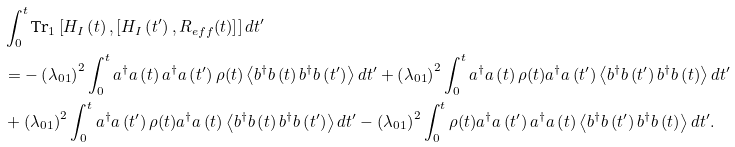Convert formula to latex. <formula><loc_0><loc_0><loc_500><loc_500>& \int _ { 0 } ^ { t } \text {Tr} _ { 1 } \left [ H _ { I } \left ( t \right ) , \left [ H _ { I } \left ( t ^ { \prime } \right ) , R _ { e f f } ( t ) \right ] \right ] d t ^ { \prime } \\ & = - \left ( \lambda _ { 0 1 } \right ) ^ { 2 } \int _ { 0 } ^ { t } a ^ { \dagger } a \left ( t \right ) a ^ { \dagger } a \left ( t ^ { \prime } \right ) \rho ( t ) \left \langle b ^ { \dagger } b \left ( t \right ) b ^ { \dagger } b \left ( t ^ { \prime } \right ) \right \rangle d t ^ { \prime } + \left ( \lambda _ { 0 1 } \right ) ^ { 2 } \int _ { 0 } ^ { t } a ^ { \dagger } a \left ( t \right ) \rho ( t ) a ^ { \dagger } a \left ( t ^ { \prime } \right ) \left \langle b ^ { \dagger } b \left ( t ^ { \prime } \right ) b ^ { \dagger } b \left ( t \right ) \right \rangle d t ^ { \prime } \\ & + \left ( \lambda _ { 0 1 } \right ) ^ { 2 } \int _ { 0 } ^ { t } a ^ { \dagger } a \left ( t ^ { \prime } \right ) \rho ( t ) a ^ { \dagger } a \left ( t \right ) \left \langle b ^ { \dagger } b \left ( t \right ) b ^ { \dagger } b \left ( t ^ { \prime } \right ) \right \rangle d t ^ { \prime } - \left ( \lambda _ { 0 1 } \right ) ^ { 2 } \int _ { 0 } ^ { t } \rho ( t ) a ^ { \dagger } a \left ( t ^ { \prime } \right ) a ^ { \dagger } a \left ( t \right ) \left \langle b ^ { \dagger } b \left ( t ^ { \prime } \right ) b ^ { \dagger } b \left ( t \right ) \right \rangle d t ^ { \prime } .</formula> 